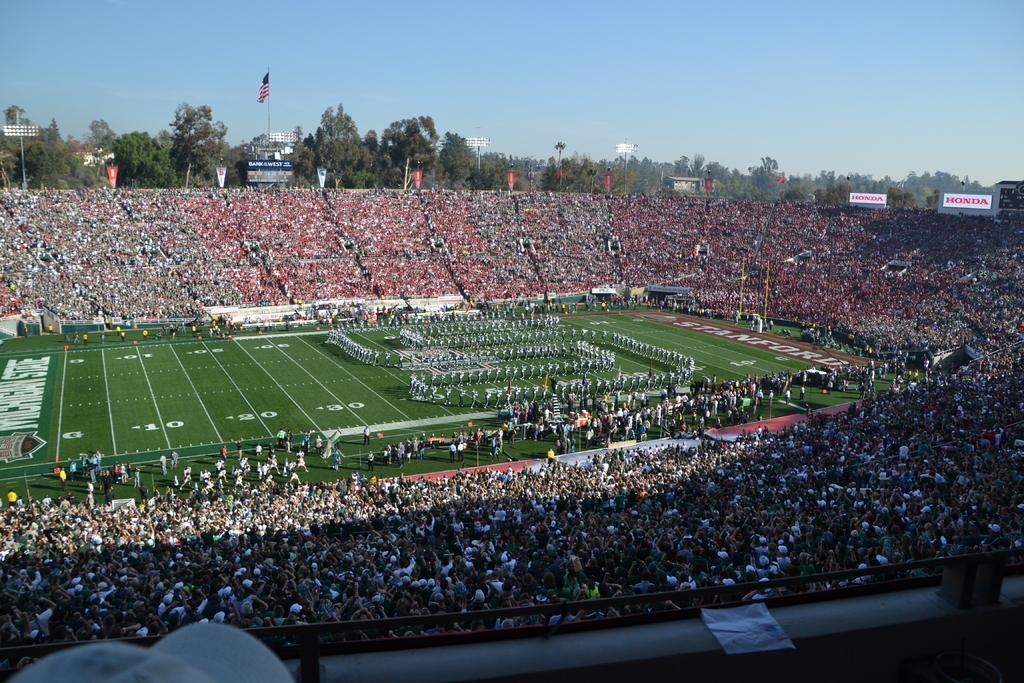How would you summarize this image in a sentence or two? In this picture I can see few people are standing on the ground and I can see audience all around and I can few boards with some text and I can see banners, trees and I can see buildings and a flag pole and I can see a blue sky and I can see flood lights to the poles. 